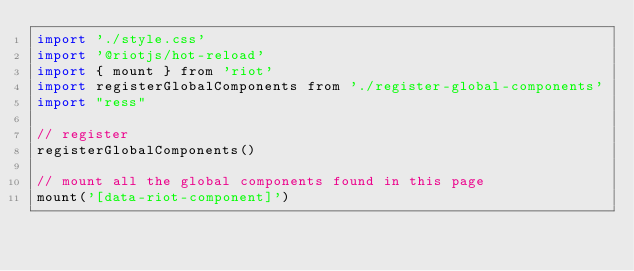<code> <loc_0><loc_0><loc_500><loc_500><_JavaScript_>import './style.css'
import '@riotjs/hot-reload'
import { mount } from 'riot'
import registerGlobalComponents from './register-global-components'
import "ress"

// register
registerGlobalComponents()

// mount all the global components found in this page
mount('[data-riot-component]')
</code> 